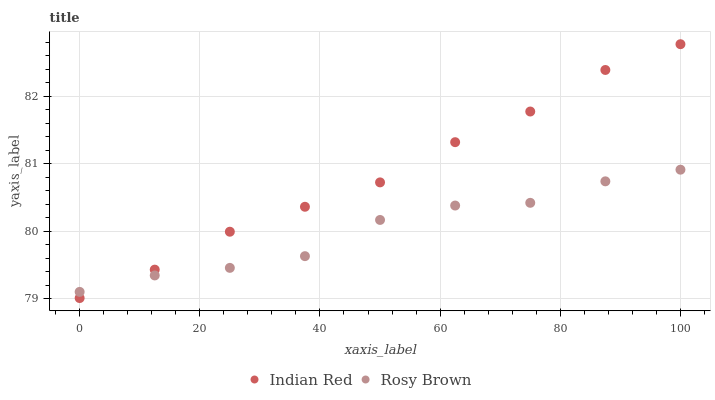Does Rosy Brown have the minimum area under the curve?
Answer yes or no. Yes. Does Indian Red have the maximum area under the curve?
Answer yes or no. Yes. Does Indian Red have the minimum area under the curve?
Answer yes or no. No. Is Indian Red the smoothest?
Answer yes or no. Yes. Is Rosy Brown the roughest?
Answer yes or no. Yes. Is Indian Red the roughest?
Answer yes or no. No. Does Indian Red have the lowest value?
Answer yes or no. Yes. Does Indian Red have the highest value?
Answer yes or no. Yes. Does Indian Red intersect Rosy Brown?
Answer yes or no. Yes. Is Indian Red less than Rosy Brown?
Answer yes or no. No. Is Indian Red greater than Rosy Brown?
Answer yes or no. No. 